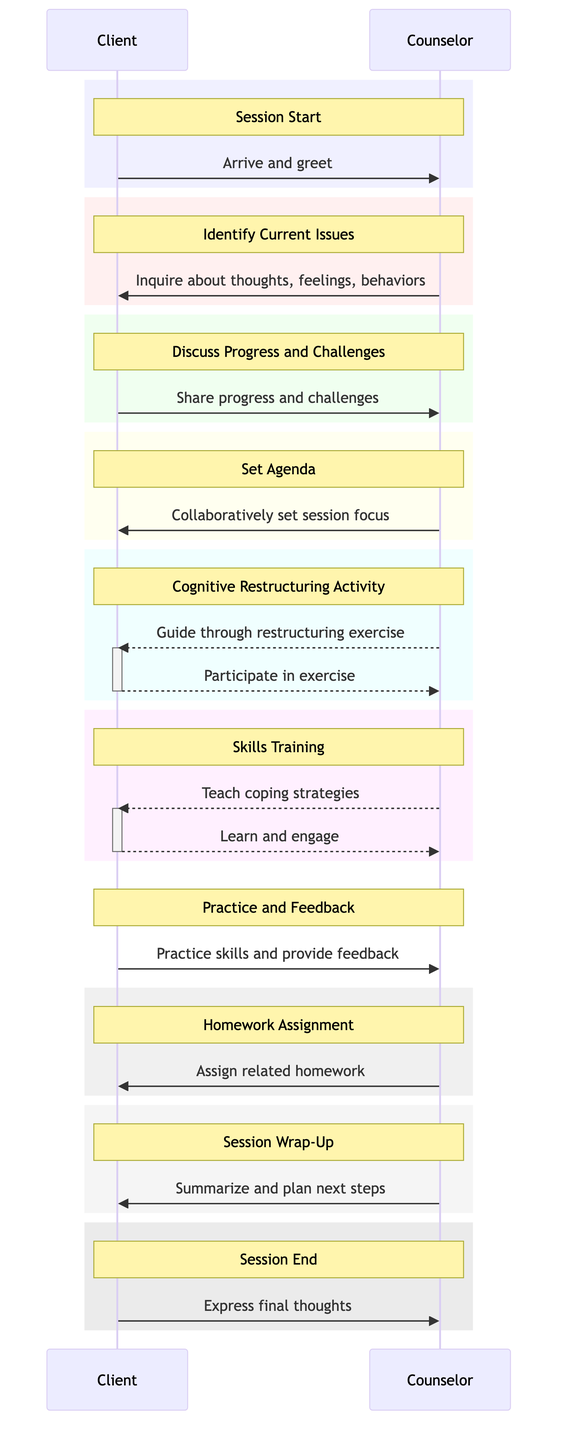What is the first message exchanged in the session? The first message exchanged in the session is when the Client arrives and greets the Counselor. This is the initial action that begins the session interaction.
Answer: Arrive and greet How many primary activities are shown in the diagram? The diagram outlines a total of 10 primary activities or messages exchanged between the Counselor and the Client, from the start to the end of the session.
Answer: 10 Which actor initiates the "Identify Current Issues" activity? The "Identify Current Issues" activity is initiated by the Counselor when they ask about the client's thoughts, feelings, and behaviors. This shows that the Counselor takes the lead in this part of the session.
Answer: Counselor What is the last action taken by the Client in the session? The last action taken by the Client in the session is expressing final thoughts or feelings before the session ends, marking the conclusion of their interaction.
Answer: Express final thoughts Which two activities involve the Counselor teaching or guiding the Client? The two activities where the Counselor teaches or guides the Client are the "Cognitive Restructuring Activity" and "Skills Training," as both involve the Counselor providing exercises and coping strategies.
Answer: Cognitive Restructuring Activity, Skills Training How does the "Session Wrap-Up" activity relate to the "Set Agenda" activity? The "Session Wrap-Up" activity is a conclusion phase that summarizes what was discussed and plans for next steps, while the "Set Agenda" activity is a preparation phase that decides the focus of that session. They are sequential, with significant action taking place between them.
Answer: Summarizing and planning next steps What kind of feedback does the Client provide during the session? During the "Practice and Feedback" activity, the Client provides feedback on the experience of practicing new skills, indicating their engagement and reflections on what they’ve learned.
Answer: Provide feedback In which phase does the Client practice new skills? The Client practices new skills during the "Practice and Feedback" phase after the Counselor teaches coping strategies and techniques. This phase allows the Client to engage actively and receive feedback.
Answer: Practice and Feedback How are assignments given for the next session? Homework Assignment is the phase where the Counselor assigns related homework to the Client regarding the skills learned or strategies discussed, ensuring continuity and practice until the next meeting.
Answer: Assign related homework 